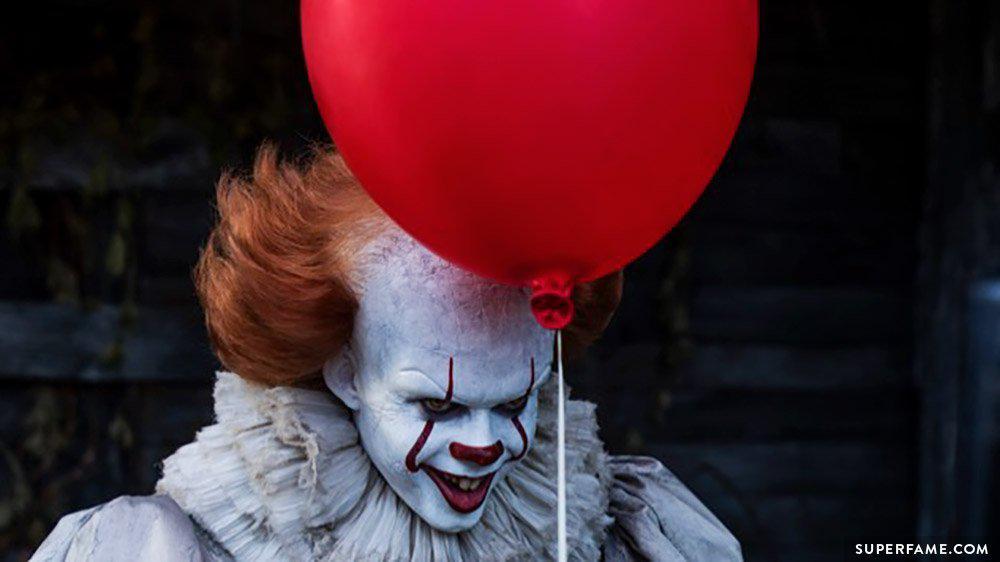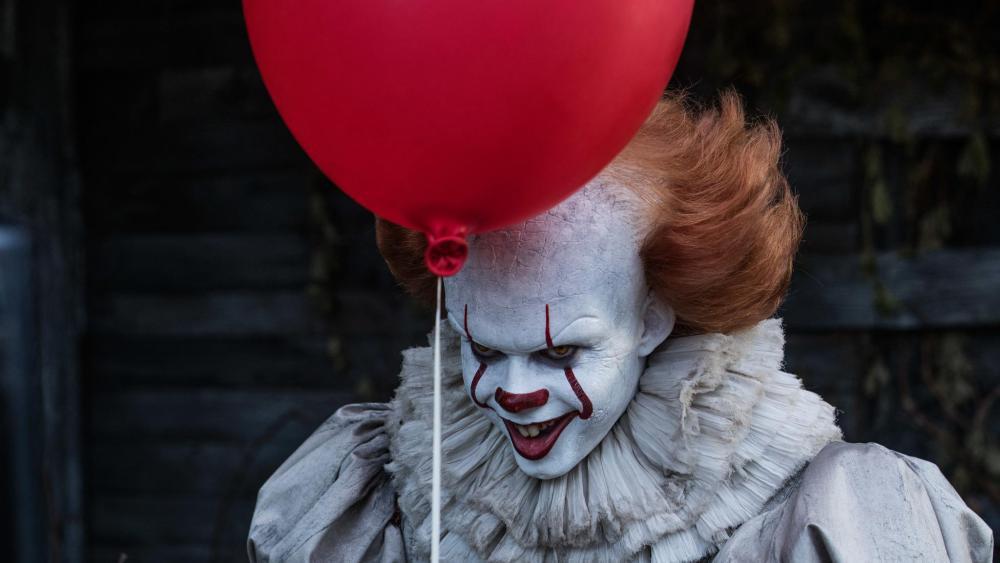The first image is the image on the left, the second image is the image on the right. Evaluate the accuracy of this statement regarding the images: "There are four eyes.". Is it true? Answer yes or no. Yes. 